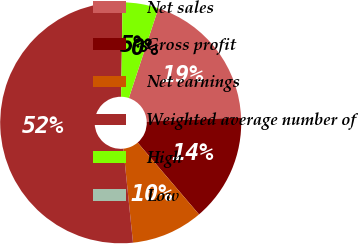Convert chart. <chart><loc_0><loc_0><loc_500><loc_500><pie_chart><fcel>Net sales<fcel>Gross profit<fcel>Net earnings<fcel>Weighted average number of<fcel>High<fcel>Low<nl><fcel>19.25%<fcel>14.44%<fcel>9.63%<fcel>51.87%<fcel>4.81%<fcel>0.0%<nl></chart> 